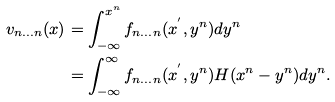<formula> <loc_0><loc_0><loc_500><loc_500>v _ { n \dots n } ( x ) & = \int _ { - \infty } ^ { x ^ { n } } f _ { n \dots n } ( x ^ { ^ { \prime } } , y ^ { n } ) d y ^ { n } \\ & = \int _ { - \infty } ^ { \infty } f _ { n \dots n } ( x ^ { ^ { \prime } } , y ^ { n } ) H ( x ^ { n } - y ^ { n } ) d y ^ { n } .</formula> 